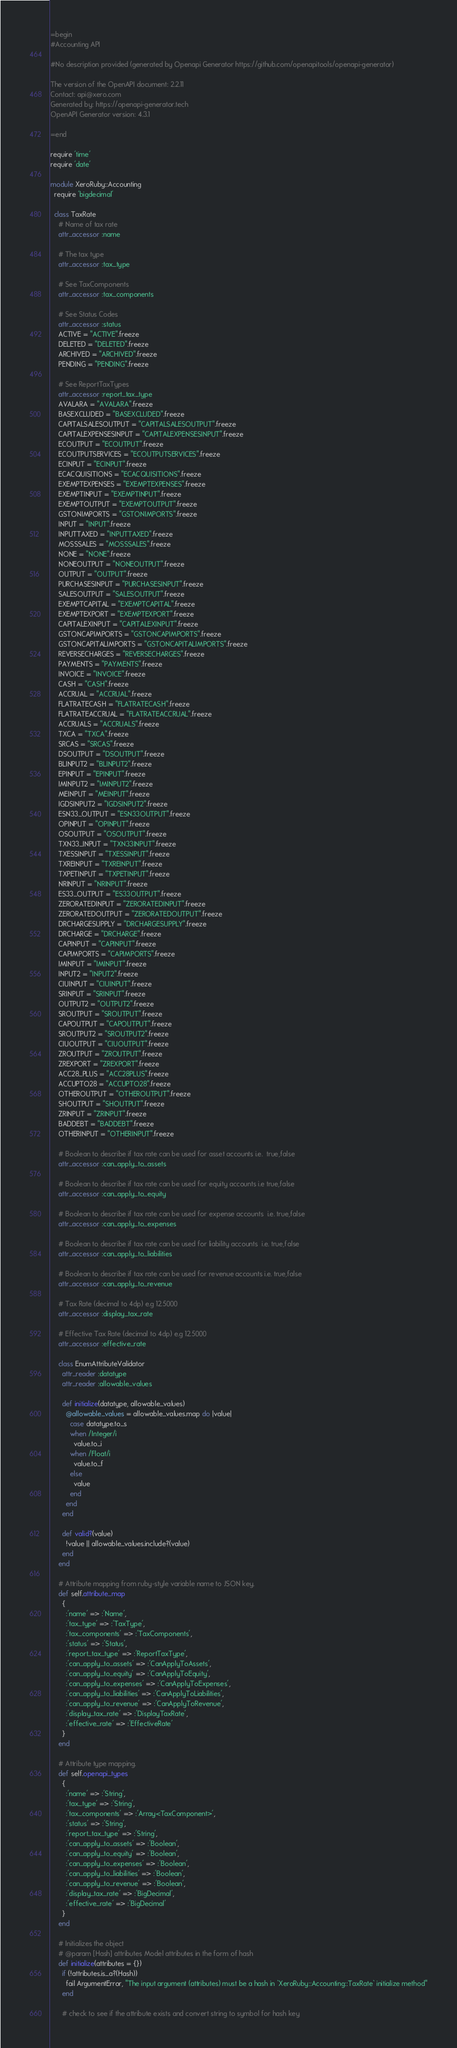Convert code to text. <code><loc_0><loc_0><loc_500><loc_500><_Ruby_>=begin
#Accounting API

#No description provided (generated by Openapi Generator https://github.com/openapitools/openapi-generator)

The version of the OpenAPI document: 2.2.11
Contact: api@xero.com
Generated by: https://openapi-generator.tech
OpenAPI Generator version: 4.3.1

=end

require 'time'
require 'date'

module XeroRuby::Accounting
  require 'bigdecimal'

  class TaxRate
    # Name of tax rate
    attr_accessor :name
    
    # The tax type
    attr_accessor :tax_type
    
    # See TaxComponents
    attr_accessor :tax_components
    
    # See Status Codes
    attr_accessor :status
    ACTIVE = "ACTIVE".freeze
    DELETED = "DELETED".freeze
    ARCHIVED = "ARCHIVED".freeze
    PENDING = "PENDING".freeze
    
    # See ReportTaxTypes
    attr_accessor :report_tax_type
    AVALARA = "AVALARA".freeze
    BASEXCLUDED = "BASEXCLUDED".freeze
    CAPITALSALESOUTPUT = "CAPITALSALESOUTPUT".freeze
    CAPITALEXPENSESINPUT = "CAPITALEXPENSESINPUT".freeze
    ECOUTPUT = "ECOUTPUT".freeze
    ECOUTPUTSERVICES = "ECOUTPUTSERVICES".freeze
    ECINPUT = "ECINPUT".freeze
    ECACQUISITIONS = "ECACQUISITIONS".freeze
    EXEMPTEXPENSES = "EXEMPTEXPENSES".freeze
    EXEMPTINPUT = "EXEMPTINPUT".freeze
    EXEMPTOUTPUT = "EXEMPTOUTPUT".freeze
    GSTONIMPORTS = "GSTONIMPORTS".freeze
    INPUT = "INPUT".freeze
    INPUTTAXED = "INPUTTAXED".freeze
    MOSSSALES = "MOSSSALES".freeze
    NONE = "NONE".freeze
    NONEOUTPUT = "NONEOUTPUT".freeze
    OUTPUT = "OUTPUT".freeze
    PURCHASESINPUT = "PURCHASESINPUT".freeze
    SALESOUTPUT = "SALESOUTPUT".freeze
    EXEMPTCAPITAL = "EXEMPTCAPITAL".freeze
    EXEMPTEXPORT = "EXEMPTEXPORT".freeze
    CAPITALEXINPUT = "CAPITALEXINPUT".freeze
    GSTONCAPIMPORTS = "GSTONCAPIMPORTS".freeze
    GSTONCAPITALIMPORTS = "GSTONCAPITALIMPORTS".freeze
    REVERSECHARGES = "REVERSECHARGES".freeze
    PAYMENTS = "PAYMENTS".freeze
    INVOICE = "INVOICE".freeze
    CASH = "CASH".freeze
    ACCRUAL = "ACCRUAL".freeze
    FLATRATECASH = "FLATRATECASH".freeze
    FLATRATEACCRUAL = "FLATRATEACCRUAL".freeze
    ACCRUALS = "ACCRUALS".freeze
    TXCA = "TXCA".freeze
    SRCAS = "SRCAS".freeze
    DSOUTPUT = "DSOUTPUT".freeze
    BLINPUT2 = "BLINPUT2".freeze
    EPINPUT = "EPINPUT".freeze
    IMINPUT2 = "IMINPUT2".freeze
    MEINPUT = "MEINPUT".freeze
    IGDSINPUT2 = "IGDSINPUT2".freeze
    ESN33_OUTPUT = "ESN33OUTPUT".freeze
    OPINPUT = "OPINPUT".freeze
    OSOUTPUT = "OSOUTPUT".freeze
    TXN33_INPUT = "TXN33INPUT".freeze
    TXESSINPUT = "TXESSINPUT".freeze
    TXREINPUT = "TXREINPUT".freeze
    TXPETINPUT = "TXPETINPUT".freeze
    NRINPUT = "NRINPUT".freeze
    ES33_OUTPUT = "ES33OUTPUT".freeze
    ZERORATEDINPUT = "ZERORATEDINPUT".freeze
    ZERORATEDOUTPUT = "ZERORATEDOUTPUT".freeze
    DRCHARGESUPPLY = "DRCHARGESUPPLY".freeze
    DRCHARGE = "DRCHARGE".freeze
    CAPINPUT = "CAPINPUT".freeze
    CAPIMPORTS = "CAPIMPORTS".freeze
    IMINPUT = "IMINPUT".freeze
    INPUT2 = "INPUT2".freeze
    CIUINPUT = "CIUINPUT".freeze
    SRINPUT = "SRINPUT".freeze
    OUTPUT2 = "OUTPUT2".freeze
    SROUTPUT = "SROUTPUT".freeze
    CAPOUTPUT = "CAPOUTPUT".freeze
    SROUTPUT2 = "SROUTPUT2".freeze
    CIUOUTPUT = "CIUOUTPUT".freeze
    ZROUTPUT = "ZROUTPUT".freeze
    ZREXPORT = "ZREXPORT".freeze
    ACC28_PLUS = "ACC28PLUS".freeze
    ACCUPTO28 = "ACCUPTO28".freeze
    OTHEROUTPUT = "OTHEROUTPUT".freeze
    SHOUTPUT = "SHOUTPUT".freeze
    ZRINPUT = "ZRINPUT".freeze
    BADDEBT = "BADDEBT".freeze
    OTHERINPUT = "OTHERINPUT".freeze
    
    # Boolean to describe if tax rate can be used for asset accounts i.e.  true,false
    attr_accessor :can_apply_to_assets
    
    # Boolean to describe if tax rate can be used for equity accounts i.e true,false
    attr_accessor :can_apply_to_equity
    
    # Boolean to describe if tax rate can be used for expense accounts  i.e. true,false
    attr_accessor :can_apply_to_expenses
    
    # Boolean to describe if tax rate can be used for liability accounts  i.e. true,false
    attr_accessor :can_apply_to_liabilities
    
    # Boolean to describe if tax rate can be used for revenue accounts i.e. true,false
    attr_accessor :can_apply_to_revenue
    
    # Tax Rate (decimal to 4dp) e.g 12.5000
    attr_accessor :display_tax_rate
    
    # Effective Tax Rate (decimal to 4dp) e.g 12.5000
    attr_accessor :effective_rate
    
    class EnumAttributeValidator
      attr_reader :datatype
      attr_reader :allowable_values

      def initialize(datatype, allowable_values)
        @allowable_values = allowable_values.map do |value|
          case datatype.to_s
          when /Integer/i
            value.to_i
          when /Float/i
            value.to_f
          else
            value
          end
        end
      end

      def valid?(value)
        !value || allowable_values.include?(value)
      end
    end

    # Attribute mapping from ruby-style variable name to JSON key.
    def self.attribute_map
      {
        :'name' => :'Name',
        :'tax_type' => :'TaxType',
        :'tax_components' => :'TaxComponents',
        :'status' => :'Status',
        :'report_tax_type' => :'ReportTaxType',
        :'can_apply_to_assets' => :'CanApplyToAssets',
        :'can_apply_to_equity' => :'CanApplyToEquity',
        :'can_apply_to_expenses' => :'CanApplyToExpenses',
        :'can_apply_to_liabilities' => :'CanApplyToLiabilities',
        :'can_apply_to_revenue' => :'CanApplyToRevenue',
        :'display_tax_rate' => :'DisplayTaxRate',
        :'effective_rate' => :'EffectiveRate'
      }
    end

    # Attribute type mapping.
    def self.openapi_types
      {
        :'name' => :'String',
        :'tax_type' => :'String',
        :'tax_components' => :'Array<TaxComponent>',
        :'status' => :'String',
        :'report_tax_type' => :'String',
        :'can_apply_to_assets' => :'Boolean',
        :'can_apply_to_equity' => :'Boolean',
        :'can_apply_to_expenses' => :'Boolean',
        :'can_apply_to_liabilities' => :'Boolean',
        :'can_apply_to_revenue' => :'Boolean',
        :'display_tax_rate' => :'BigDecimal',
        :'effective_rate' => :'BigDecimal'
      }
    end

    # Initializes the object
    # @param [Hash] attributes Model attributes in the form of hash
    def initialize(attributes = {})
      if (!attributes.is_a?(Hash))
        fail ArgumentError, "The input argument (attributes) must be a hash in `XeroRuby::Accounting::TaxRate` initialize method"
      end

      # check to see if the attribute exists and convert string to symbol for hash key</code> 